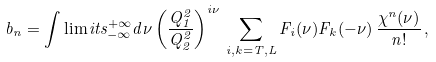Convert formula to latex. <formula><loc_0><loc_0><loc_500><loc_500>b _ { n } = \int \lim i t s ^ { + \infty } _ { - \infty } d \nu \left ( \frac { Q _ { 1 } ^ { 2 } } { Q _ { 2 } ^ { 2 } } \right ) ^ { i \nu } \, \sum _ { i , k = T , L } F _ { i } ( \nu ) F _ { k } ( - \nu ) \, \frac { \chi ^ { n } ( \nu ) } { n ! } \, ,</formula> 